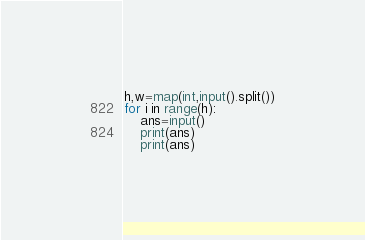<code> <loc_0><loc_0><loc_500><loc_500><_Python_>h,w=map(int,input().split())
for i in range(h):
    ans=input()
    print(ans)
    print(ans)</code> 